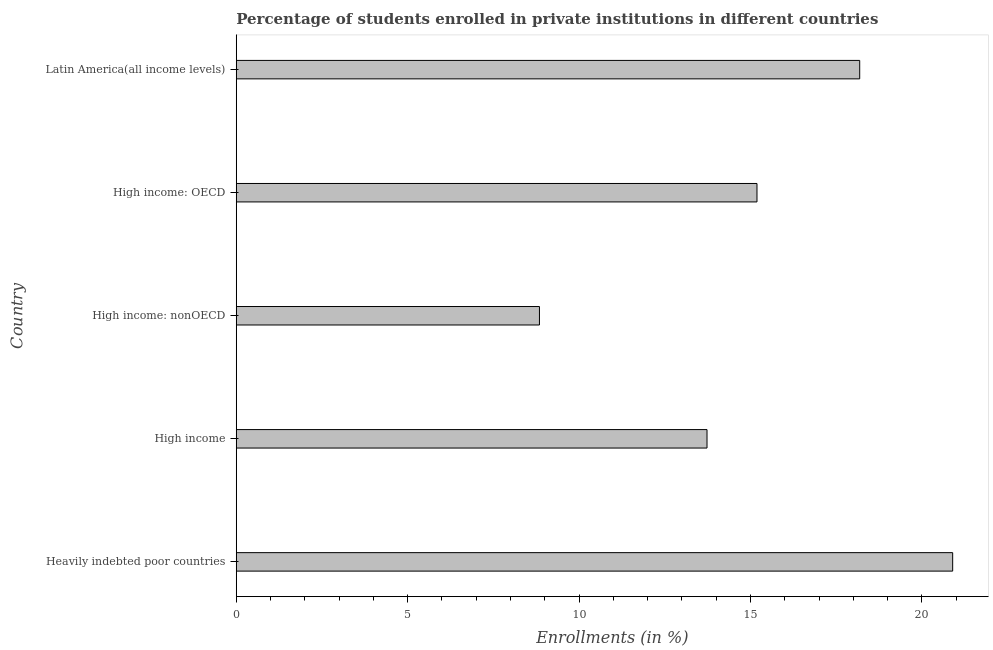What is the title of the graph?
Your answer should be compact. Percentage of students enrolled in private institutions in different countries. What is the label or title of the X-axis?
Offer a very short reply. Enrollments (in %). What is the label or title of the Y-axis?
Provide a succinct answer. Country. What is the enrollments in private institutions in Heavily indebted poor countries?
Your answer should be compact. 20.9. Across all countries, what is the maximum enrollments in private institutions?
Make the answer very short. 20.9. Across all countries, what is the minimum enrollments in private institutions?
Your answer should be compact. 8.84. In which country was the enrollments in private institutions maximum?
Offer a very short reply. Heavily indebted poor countries. In which country was the enrollments in private institutions minimum?
Your response must be concise. High income: nonOECD. What is the sum of the enrollments in private institutions?
Keep it short and to the point. 76.85. What is the difference between the enrollments in private institutions in High income and Latin America(all income levels)?
Provide a short and direct response. -4.45. What is the average enrollments in private institutions per country?
Keep it short and to the point. 15.37. What is the median enrollments in private institutions?
Offer a terse response. 15.19. In how many countries, is the enrollments in private institutions greater than 6 %?
Your response must be concise. 5. What is the ratio of the enrollments in private institutions in High income: OECD to that in High income: nonOECD?
Offer a terse response. 1.72. Is the enrollments in private institutions in High income less than that in Latin America(all income levels)?
Offer a very short reply. Yes. What is the difference between the highest and the second highest enrollments in private institutions?
Offer a terse response. 2.71. What is the difference between the highest and the lowest enrollments in private institutions?
Ensure brevity in your answer.  12.05. How many bars are there?
Your answer should be very brief. 5. How many countries are there in the graph?
Offer a terse response. 5. What is the difference between two consecutive major ticks on the X-axis?
Your answer should be compact. 5. Are the values on the major ticks of X-axis written in scientific E-notation?
Make the answer very short. No. What is the Enrollments (in %) in Heavily indebted poor countries?
Ensure brevity in your answer.  20.9. What is the Enrollments (in %) of High income?
Your response must be concise. 13.73. What is the Enrollments (in %) of High income: nonOECD?
Make the answer very short. 8.84. What is the Enrollments (in %) of High income: OECD?
Offer a terse response. 15.19. What is the Enrollments (in %) in Latin America(all income levels)?
Your response must be concise. 18.19. What is the difference between the Enrollments (in %) in Heavily indebted poor countries and High income?
Your answer should be compact. 7.17. What is the difference between the Enrollments (in %) in Heavily indebted poor countries and High income: nonOECD?
Offer a terse response. 12.05. What is the difference between the Enrollments (in %) in Heavily indebted poor countries and High income: OECD?
Your answer should be very brief. 5.71. What is the difference between the Enrollments (in %) in Heavily indebted poor countries and Latin America(all income levels)?
Your answer should be compact. 2.71. What is the difference between the Enrollments (in %) in High income and High income: nonOECD?
Make the answer very short. 4.89. What is the difference between the Enrollments (in %) in High income and High income: OECD?
Give a very brief answer. -1.46. What is the difference between the Enrollments (in %) in High income and Latin America(all income levels)?
Give a very brief answer. -4.45. What is the difference between the Enrollments (in %) in High income: nonOECD and High income: OECD?
Keep it short and to the point. -6.35. What is the difference between the Enrollments (in %) in High income: nonOECD and Latin America(all income levels)?
Your answer should be very brief. -9.34. What is the difference between the Enrollments (in %) in High income: OECD and Latin America(all income levels)?
Your answer should be very brief. -3. What is the ratio of the Enrollments (in %) in Heavily indebted poor countries to that in High income?
Give a very brief answer. 1.52. What is the ratio of the Enrollments (in %) in Heavily indebted poor countries to that in High income: nonOECD?
Make the answer very short. 2.36. What is the ratio of the Enrollments (in %) in Heavily indebted poor countries to that in High income: OECD?
Your answer should be compact. 1.38. What is the ratio of the Enrollments (in %) in Heavily indebted poor countries to that in Latin America(all income levels)?
Make the answer very short. 1.15. What is the ratio of the Enrollments (in %) in High income to that in High income: nonOECD?
Provide a succinct answer. 1.55. What is the ratio of the Enrollments (in %) in High income to that in High income: OECD?
Provide a succinct answer. 0.9. What is the ratio of the Enrollments (in %) in High income to that in Latin America(all income levels)?
Your response must be concise. 0.76. What is the ratio of the Enrollments (in %) in High income: nonOECD to that in High income: OECD?
Make the answer very short. 0.58. What is the ratio of the Enrollments (in %) in High income: nonOECD to that in Latin America(all income levels)?
Make the answer very short. 0.49. What is the ratio of the Enrollments (in %) in High income: OECD to that in Latin America(all income levels)?
Your answer should be compact. 0.83. 